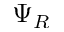<formula> <loc_0><loc_0><loc_500><loc_500>\Psi _ { R }</formula> 